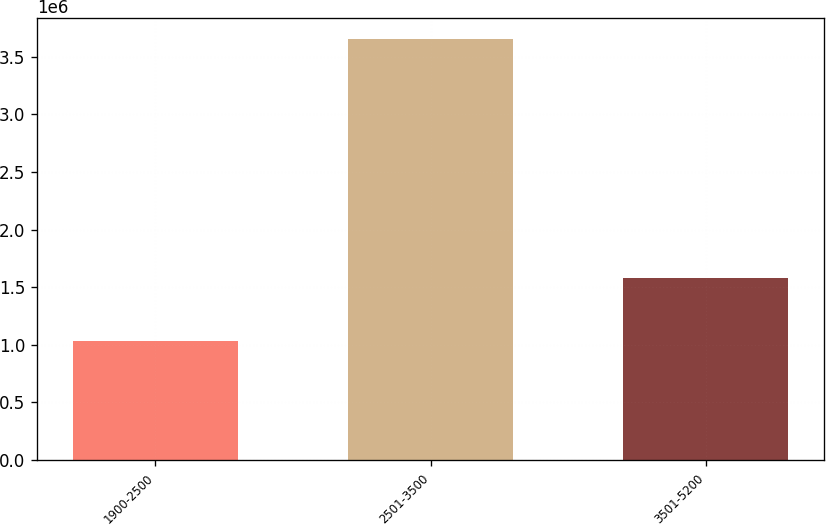Convert chart to OTSL. <chart><loc_0><loc_0><loc_500><loc_500><bar_chart><fcel>1900-2500<fcel>2501-3500<fcel>3501-5200<nl><fcel>1.02934e+06<fcel>3.65096e+06<fcel>1.57926e+06<nl></chart> 